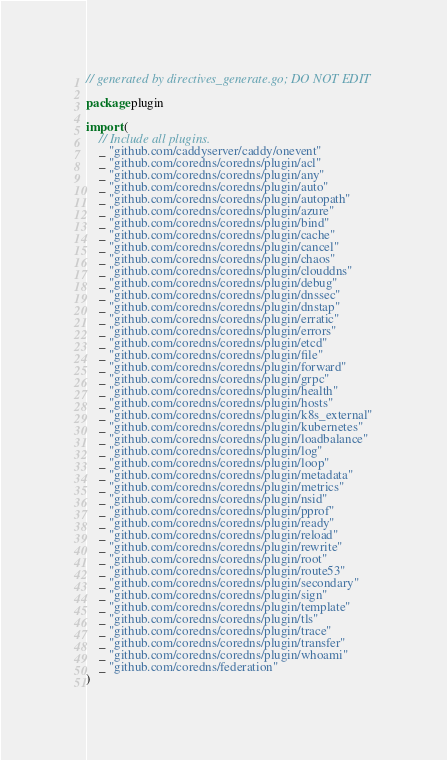Convert code to text. <code><loc_0><loc_0><loc_500><loc_500><_Go_>// generated by directives_generate.go; DO NOT EDIT

package plugin

import (
	// Include all plugins.
	_ "github.com/caddyserver/caddy/onevent"
	_ "github.com/coredns/coredns/plugin/acl"
	_ "github.com/coredns/coredns/plugin/any"
	_ "github.com/coredns/coredns/plugin/auto"
	_ "github.com/coredns/coredns/plugin/autopath"
	_ "github.com/coredns/coredns/plugin/azure"
	_ "github.com/coredns/coredns/plugin/bind"
	_ "github.com/coredns/coredns/plugin/cache"
	_ "github.com/coredns/coredns/plugin/cancel"
	_ "github.com/coredns/coredns/plugin/chaos"
	_ "github.com/coredns/coredns/plugin/clouddns"
	_ "github.com/coredns/coredns/plugin/debug"
	_ "github.com/coredns/coredns/plugin/dnssec"
	_ "github.com/coredns/coredns/plugin/dnstap"
	_ "github.com/coredns/coredns/plugin/erratic"
	_ "github.com/coredns/coredns/plugin/errors"
	_ "github.com/coredns/coredns/plugin/etcd"
	_ "github.com/coredns/coredns/plugin/file"
	_ "github.com/coredns/coredns/plugin/forward"
	_ "github.com/coredns/coredns/plugin/grpc"
	_ "github.com/coredns/coredns/plugin/health"
	_ "github.com/coredns/coredns/plugin/hosts"
	_ "github.com/coredns/coredns/plugin/k8s_external"
	_ "github.com/coredns/coredns/plugin/kubernetes"
	_ "github.com/coredns/coredns/plugin/loadbalance"
	_ "github.com/coredns/coredns/plugin/log"
	_ "github.com/coredns/coredns/plugin/loop"
	_ "github.com/coredns/coredns/plugin/metadata"
	_ "github.com/coredns/coredns/plugin/metrics"
	_ "github.com/coredns/coredns/plugin/nsid"
	_ "github.com/coredns/coredns/plugin/pprof"
	_ "github.com/coredns/coredns/plugin/ready"
	_ "github.com/coredns/coredns/plugin/reload"
	_ "github.com/coredns/coredns/plugin/rewrite"
	_ "github.com/coredns/coredns/plugin/root"
	_ "github.com/coredns/coredns/plugin/route53"
	_ "github.com/coredns/coredns/plugin/secondary"
	_ "github.com/coredns/coredns/plugin/sign"
	_ "github.com/coredns/coredns/plugin/template"
	_ "github.com/coredns/coredns/plugin/tls"
	_ "github.com/coredns/coredns/plugin/trace"
	_ "github.com/coredns/coredns/plugin/transfer"
	_ "github.com/coredns/coredns/plugin/whoami"
	_ "github.com/coredns/federation"
)
</code> 